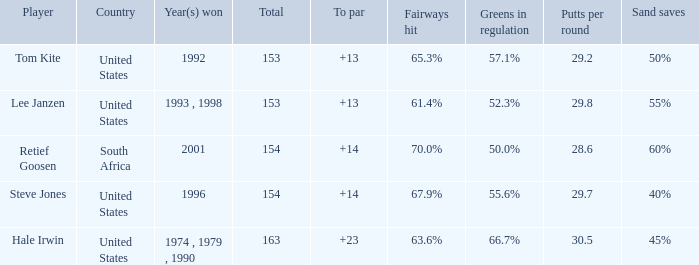In what year did the United States win To par greater than 14 1974 , 1979 , 1990. 